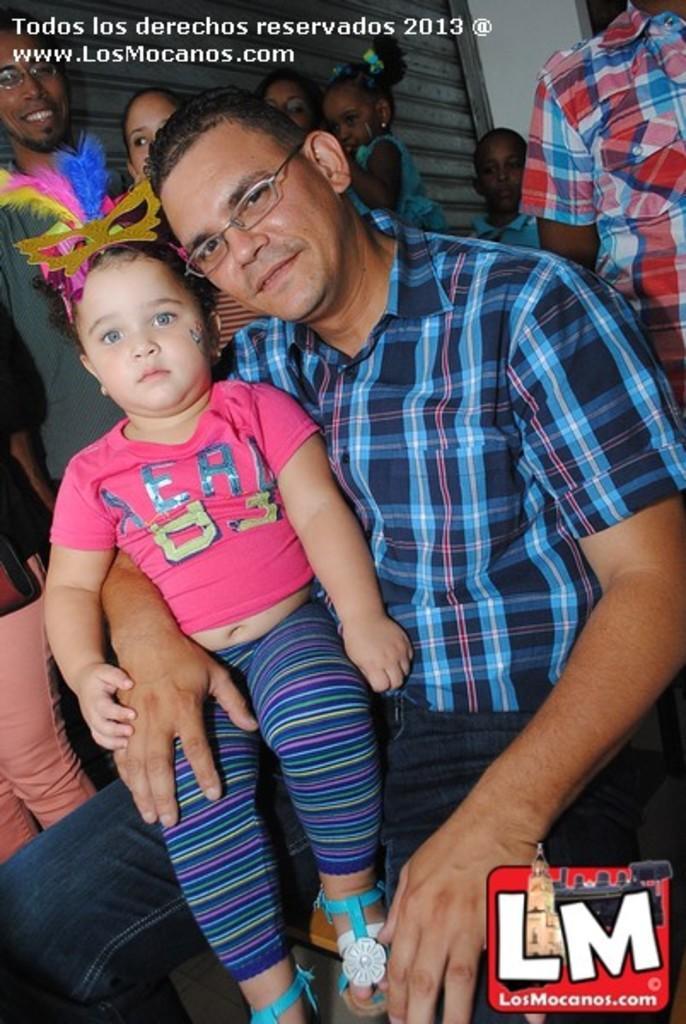Please provide a concise description of this image. There is one man sitting and holding a baby in the middle of this image. We can see a group of people and a wall in the background. There is a text watermark at the top of this image and there is a logo in the bottom right corner of this image. 